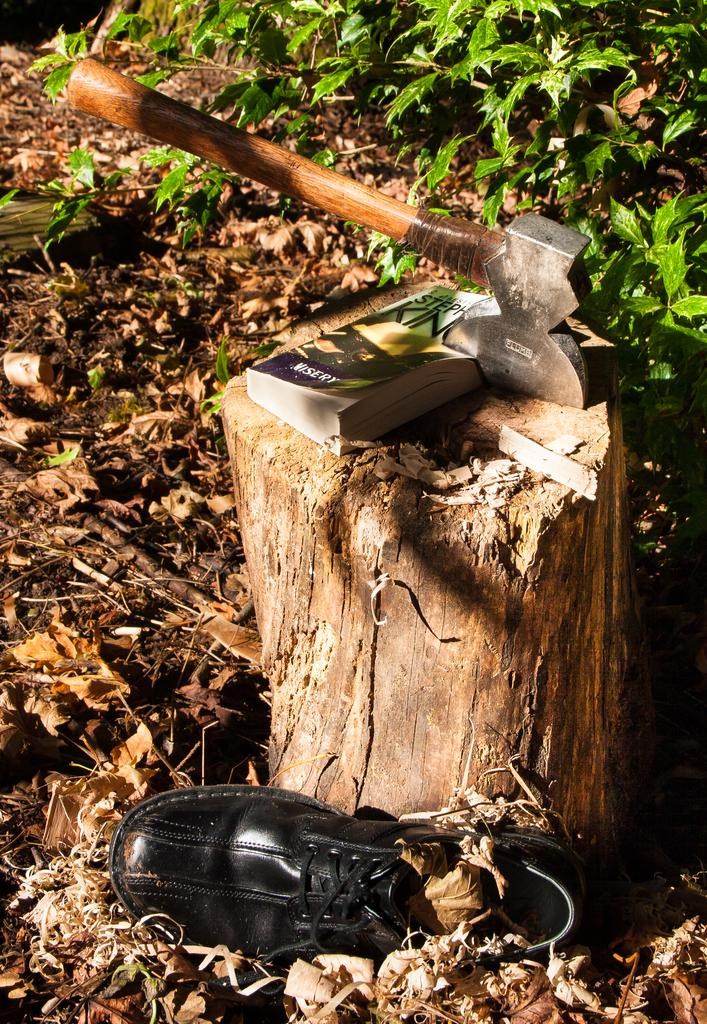What object in the image is typically used for chopping or splitting wood? There is an axe in the image, which is typically used for chopping or splitting wood. What is the book resting on in the image? The book is on a small wooden log in the image. What can be seen at the bottom of the image? There is a shoe at the bottom of the image. What type of vegetation is visible in the background of the image? Plants are visible in the background of the image. What is present on the ground in the background of the image? Leaves are visible on the ground in the background of the image. What type of skirt is being worn by the nation in the image? There is no nation or skirt present in the image. What songs can be heard playing in the background of the image? There is no audio or music present in the image. 